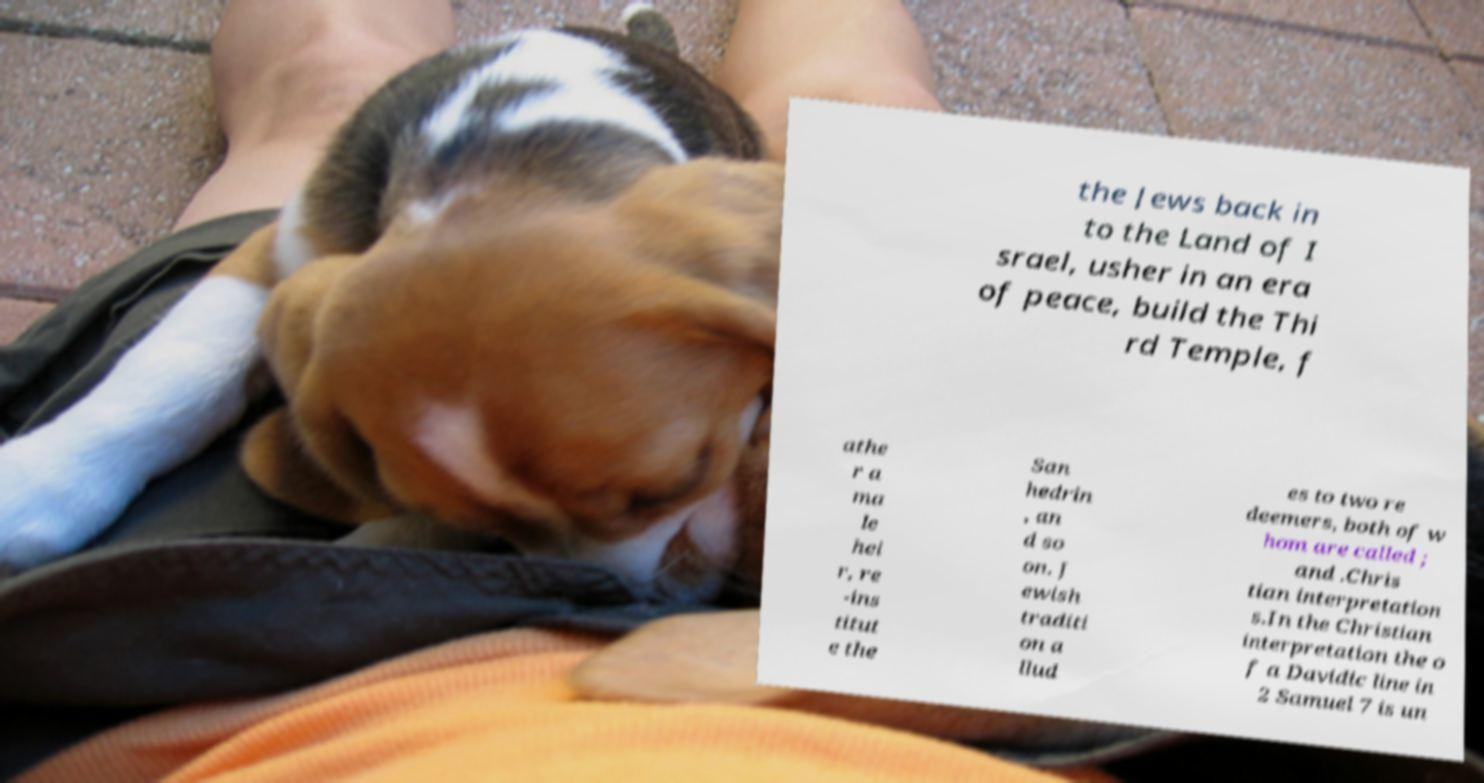What messages or text are displayed in this image? I need them in a readable, typed format. the Jews back in to the Land of I srael, usher in an era of peace, build the Thi rd Temple, f athe r a ma le hei r, re -ins titut e the San hedrin , an d so on. J ewish traditi on a llud es to two re deemers, both of w hom are called ; and .Chris tian interpretation s.In the Christian interpretation the o f a Davidic line in 2 Samuel 7 is un 